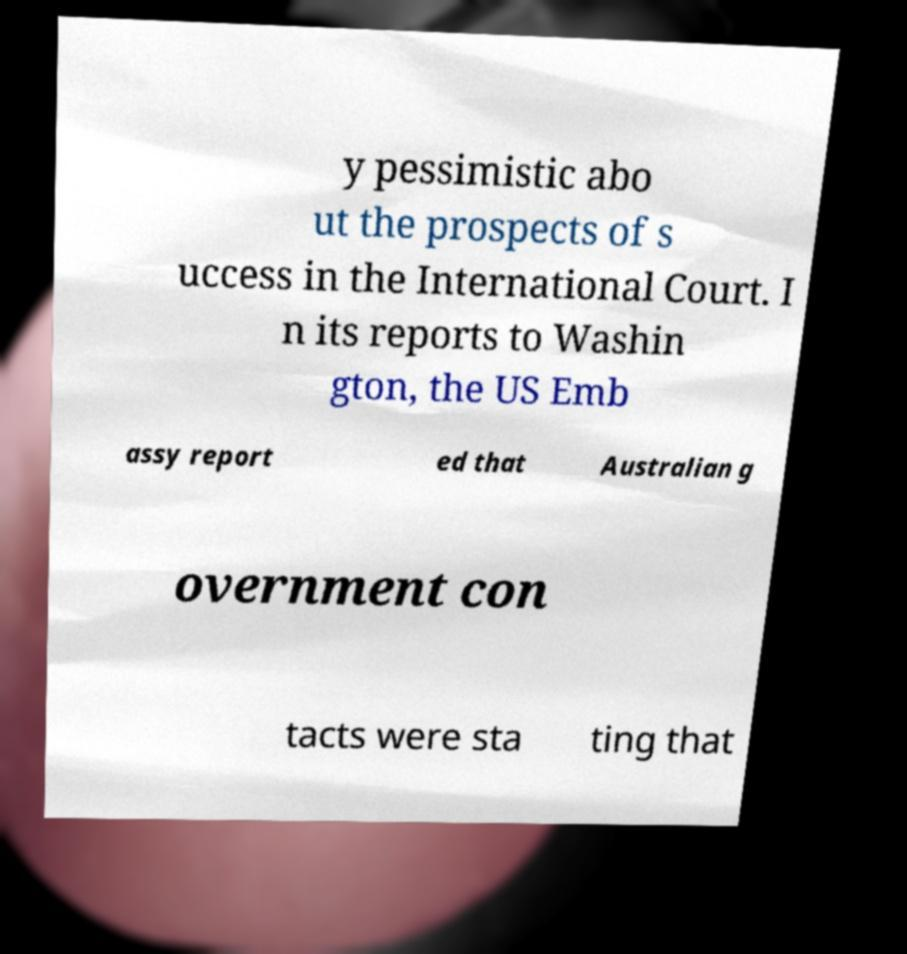Could you assist in decoding the text presented in this image and type it out clearly? y pessimistic abo ut the prospects of s uccess in the International Court. I n its reports to Washin gton, the US Emb assy report ed that Australian g overnment con tacts were sta ting that 